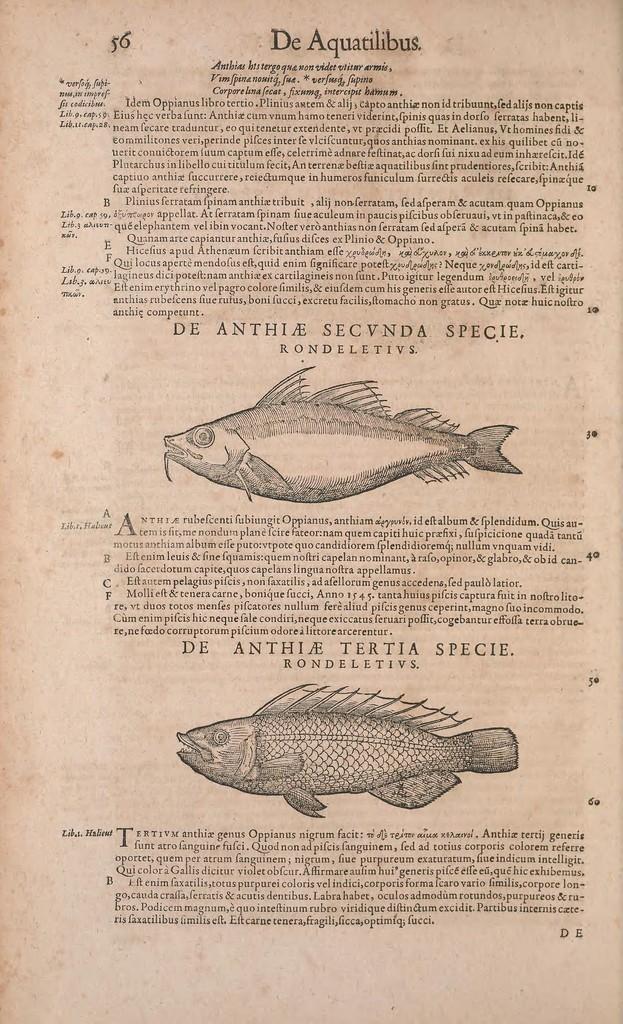Can you describe this image briefly? In this image I can see a paper on which there are images of fishes and some matter is written. 